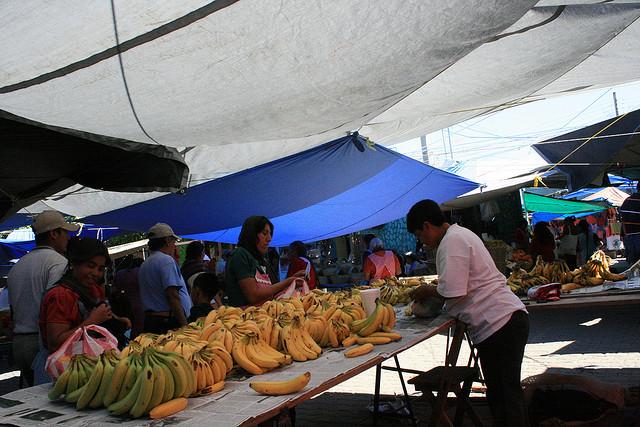What is covering the table underneath the bananas?
Write a very short answer. Newspaper. Was it a sunny day when this picture was taken?
Quick response, please. Yes. How many people are under the tent?
Quick response, please. 10. What color is the tent?
Quick response, please. White. What fruits are shown?
Keep it brief. Bananas. 